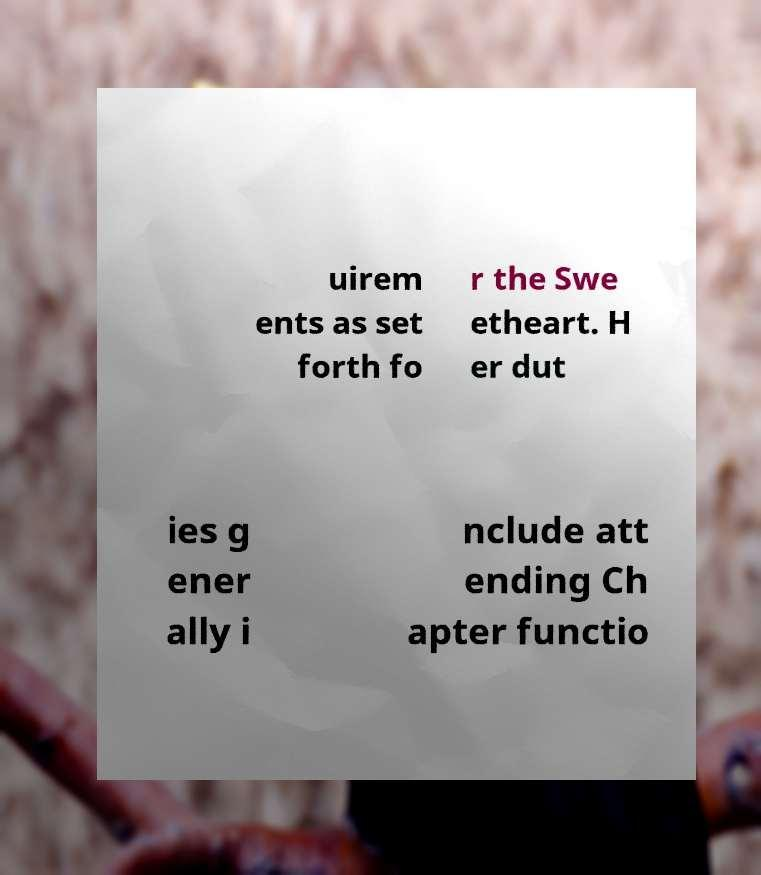I need the written content from this picture converted into text. Can you do that? uirem ents as set forth fo r the Swe etheart. H er dut ies g ener ally i nclude att ending Ch apter functio 